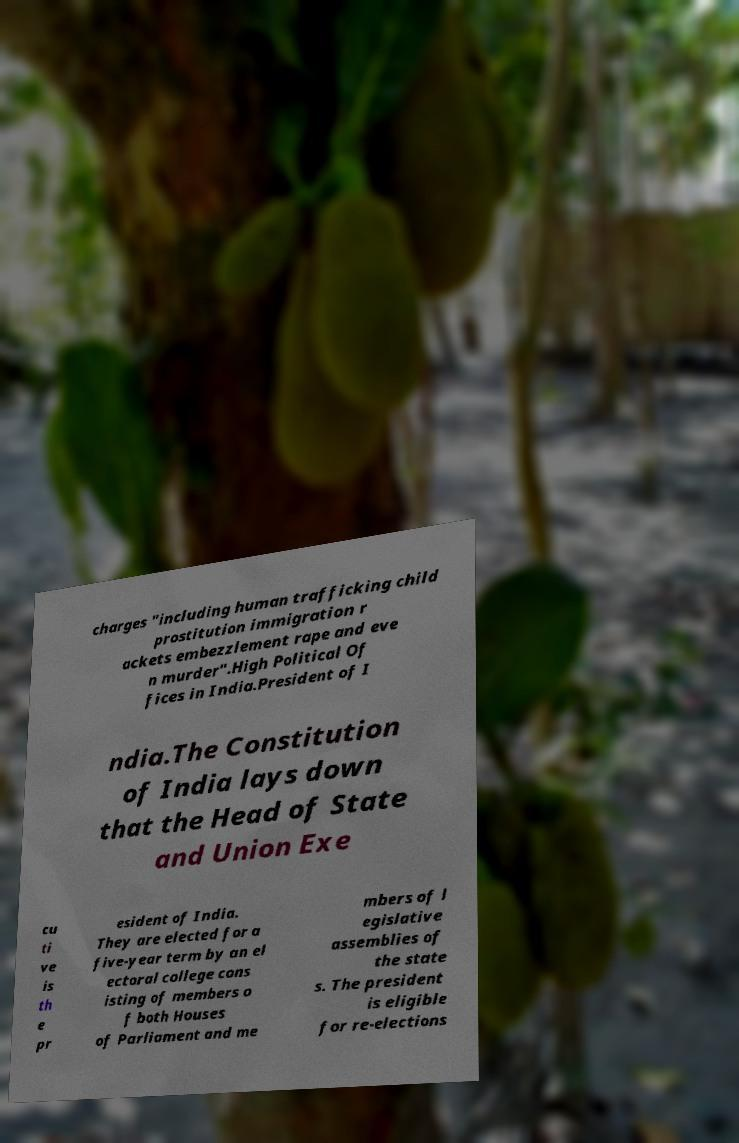Please read and relay the text visible in this image. What does it say? charges "including human trafficking child prostitution immigration r ackets embezzlement rape and eve n murder".High Political Of fices in India.President of I ndia.The Constitution of India lays down that the Head of State and Union Exe cu ti ve is th e pr esident of India. They are elected for a five-year term by an el ectoral college cons isting of members o f both Houses of Parliament and me mbers of l egislative assemblies of the state s. The president is eligible for re-elections 